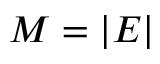Convert formula to latex. <formula><loc_0><loc_0><loc_500><loc_500>M = | E |</formula> 